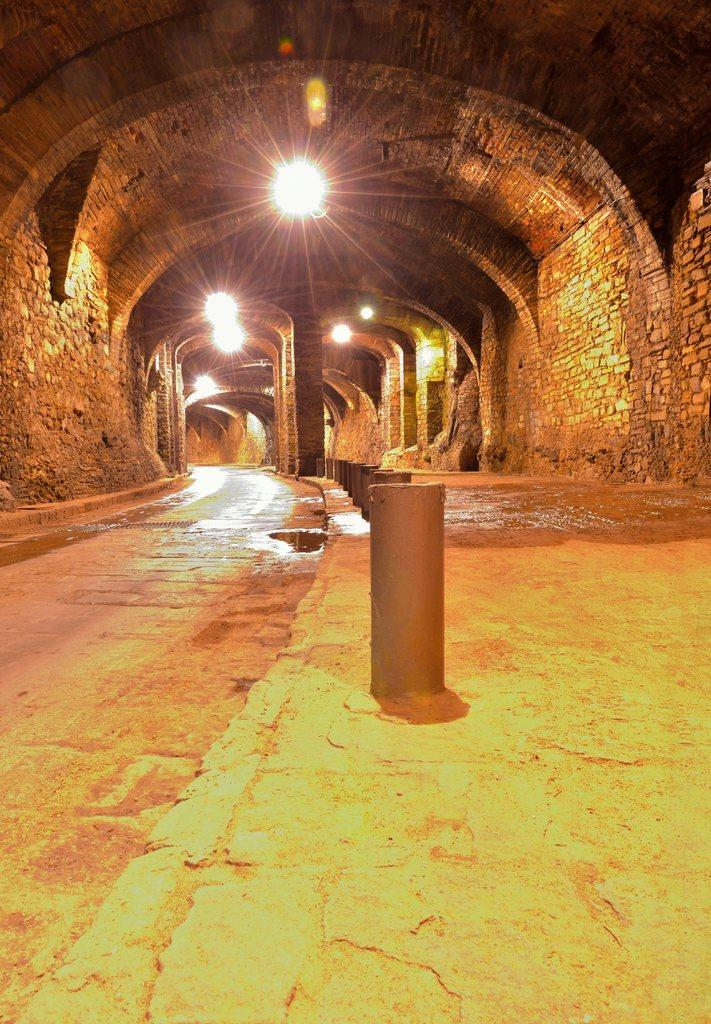What is the main structure in the image? There is a tunnel in the image. What feature can be seen attached to the tunnel? There are lights attached to the tunnel. What is present on the ground in the image? There is water on the ground in the image. What type of support structures are visible in the image? There are pillars and concrete poles in the image. Who is the owner of the sink in the image? There is no sink present in the image. How many screws are visible in the image? There are no screws mentioned or visible in the image. 